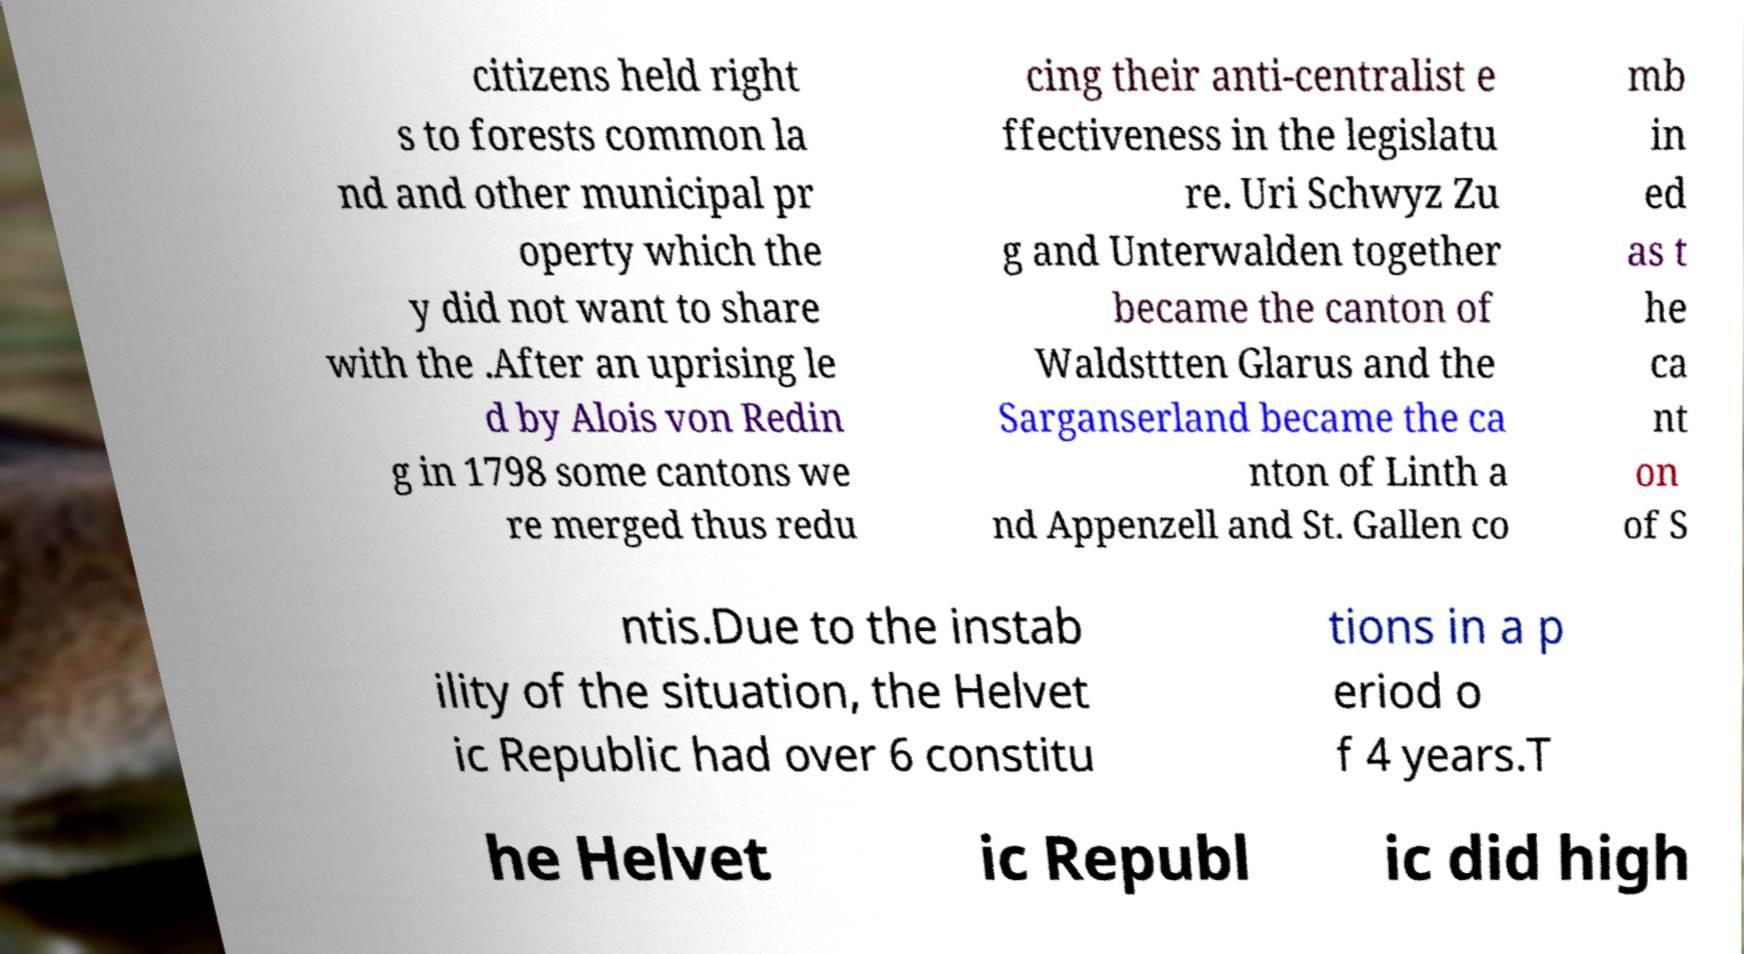Could you extract and type out the text from this image? citizens held right s to forests common la nd and other municipal pr operty which the y did not want to share with the .After an uprising le d by Alois von Redin g in 1798 some cantons we re merged thus redu cing their anti-centralist e ffectiveness in the legislatu re. Uri Schwyz Zu g and Unterwalden together became the canton of Waldsttten Glarus and the Sarganserland became the ca nton of Linth a nd Appenzell and St. Gallen co mb in ed as t he ca nt on of S ntis.Due to the instab ility of the situation, the Helvet ic Republic had over 6 constitu tions in a p eriod o f 4 years.T he Helvet ic Republ ic did high 